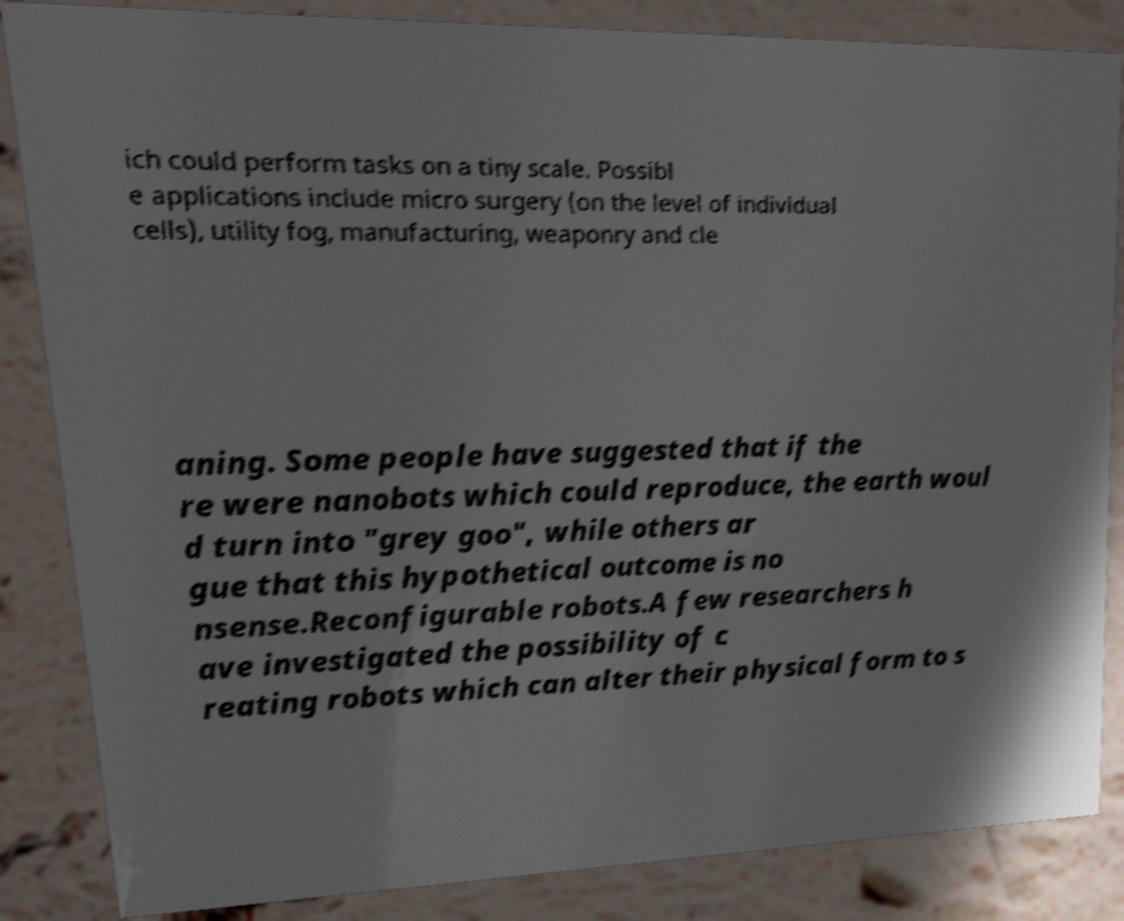Could you extract and type out the text from this image? ich could perform tasks on a tiny scale. Possibl e applications include micro surgery (on the level of individual cells), utility fog, manufacturing, weaponry and cle aning. Some people have suggested that if the re were nanobots which could reproduce, the earth woul d turn into "grey goo", while others ar gue that this hypothetical outcome is no nsense.Reconfigurable robots.A few researchers h ave investigated the possibility of c reating robots which can alter their physical form to s 